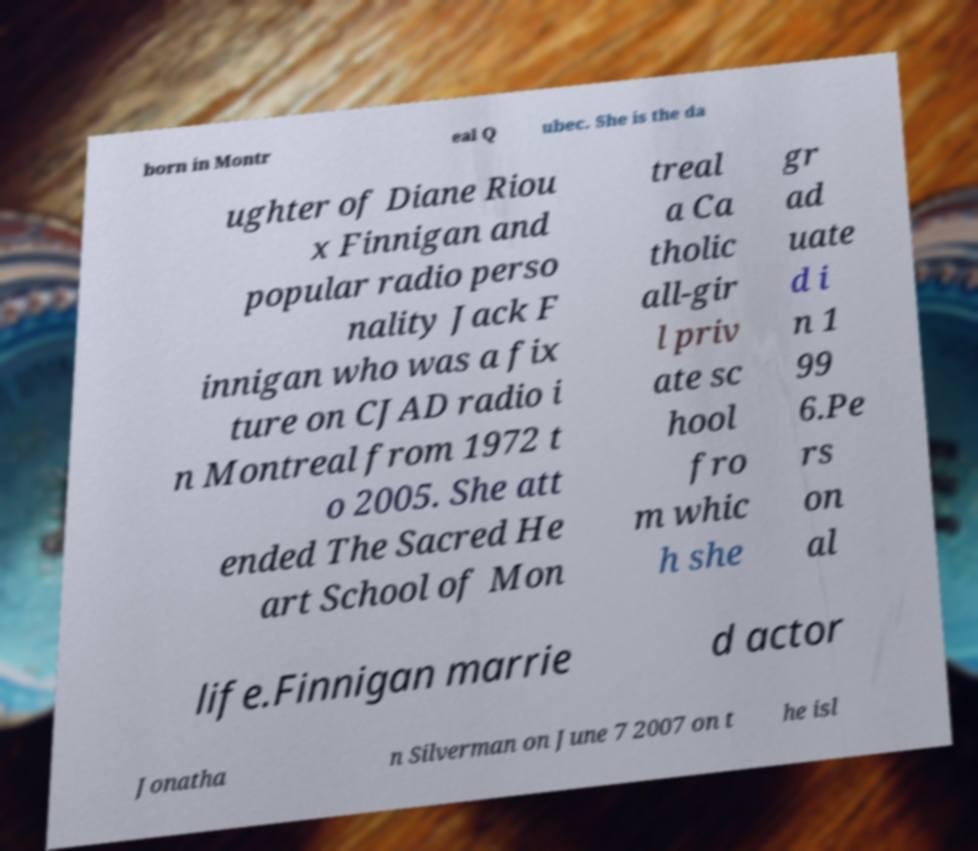Could you assist in decoding the text presented in this image and type it out clearly? born in Montr eal Q ubec. She is the da ughter of Diane Riou x Finnigan and popular radio perso nality Jack F innigan who was a fix ture on CJAD radio i n Montreal from 1972 t o 2005. She att ended The Sacred He art School of Mon treal a Ca tholic all-gir l priv ate sc hool fro m whic h she gr ad uate d i n 1 99 6.Pe rs on al life.Finnigan marrie d actor Jonatha n Silverman on June 7 2007 on t he isl 